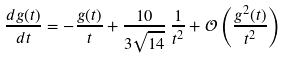<formula> <loc_0><loc_0><loc_500><loc_500>\frac { d g ( t ) } { d t } = - \frac { g ( t ) } { t } + \frac { 1 0 } { 3 \sqrt { 1 4 } } \, \frac { 1 } { t ^ { 2 } } + \mathcal { O } \left ( \frac { g ^ { 2 } ( t ) } { t ^ { 2 } } \right )</formula> 